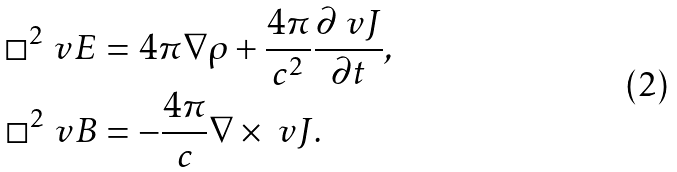Convert formula to latex. <formula><loc_0><loc_0><loc_500><loc_500>\Box ^ { 2 } \ v E & = 4 \pi \nabla \rho + \frac { 4 \pi } { c ^ { 2 } } \frac { \partial \ v J } { \partial t } , \\ \Box ^ { 2 } \ v B & = - \frac { 4 \pi } { c } \nabla \times \ v J .</formula> 